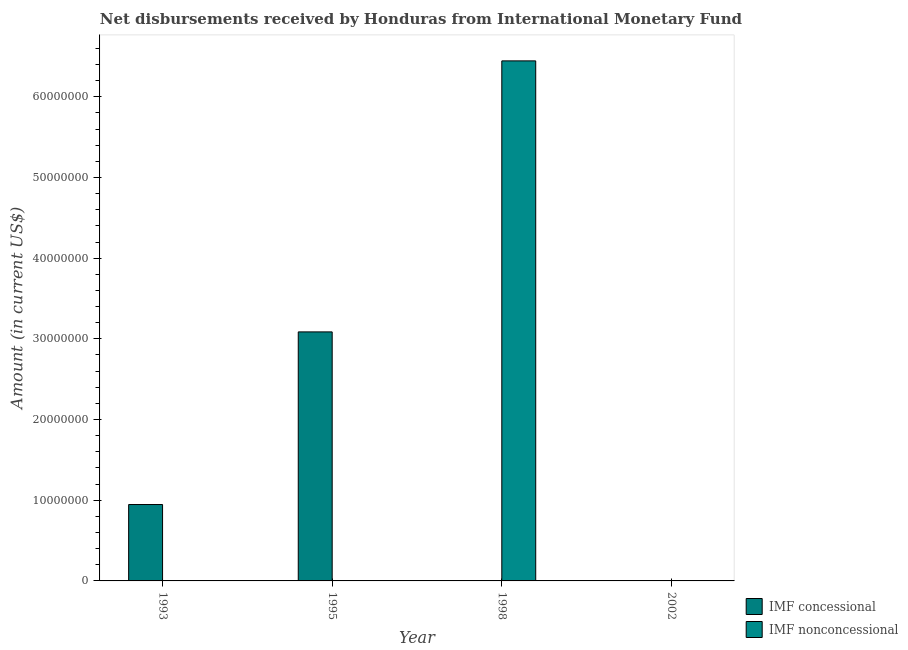Are the number of bars on each tick of the X-axis equal?
Ensure brevity in your answer.  No. How many bars are there on the 1st tick from the right?
Keep it short and to the point. 0. In how many cases, is the number of bars for a given year not equal to the number of legend labels?
Your answer should be compact. 4. Across all years, what is the maximum net concessional disbursements from imf?
Make the answer very short. 3.09e+07. What is the total net concessional disbursements from imf in the graph?
Your answer should be compact. 4.03e+07. What is the difference between the net concessional disbursements from imf in 1993 and that in 1995?
Offer a terse response. -2.14e+07. What is the average net non concessional disbursements from imf per year?
Give a very brief answer. 1.61e+07. What is the difference between the highest and the lowest net non concessional disbursements from imf?
Offer a terse response. 6.44e+07. Is the sum of the net concessional disbursements from imf in 1993 and 1995 greater than the maximum net non concessional disbursements from imf across all years?
Your answer should be compact. Yes. Are all the bars in the graph horizontal?
Your answer should be compact. No. How many years are there in the graph?
Make the answer very short. 4. What is the difference between two consecutive major ticks on the Y-axis?
Ensure brevity in your answer.  1.00e+07. Are the values on the major ticks of Y-axis written in scientific E-notation?
Your answer should be compact. No. Does the graph contain any zero values?
Your response must be concise. Yes. Does the graph contain grids?
Your answer should be very brief. No. What is the title of the graph?
Provide a succinct answer. Net disbursements received by Honduras from International Monetary Fund. What is the label or title of the X-axis?
Provide a short and direct response. Year. What is the label or title of the Y-axis?
Your response must be concise. Amount (in current US$). What is the Amount (in current US$) of IMF concessional in 1993?
Your answer should be compact. 9.47e+06. What is the Amount (in current US$) in IMF nonconcessional in 1993?
Make the answer very short. 0. What is the Amount (in current US$) of IMF concessional in 1995?
Give a very brief answer. 3.09e+07. What is the Amount (in current US$) in IMF nonconcessional in 1995?
Give a very brief answer. 0. What is the Amount (in current US$) in IMF nonconcessional in 1998?
Keep it short and to the point. 6.44e+07. What is the Amount (in current US$) in IMF concessional in 2002?
Make the answer very short. 0. Across all years, what is the maximum Amount (in current US$) of IMF concessional?
Make the answer very short. 3.09e+07. Across all years, what is the maximum Amount (in current US$) in IMF nonconcessional?
Your answer should be compact. 6.44e+07. Across all years, what is the minimum Amount (in current US$) in IMF concessional?
Offer a very short reply. 0. What is the total Amount (in current US$) in IMF concessional in the graph?
Make the answer very short. 4.03e+07. What is the total Amount (in current US$) in IMF nonconcessional in the graph?
Offer a terse response. 6.44e+07. What is the difference between the Amount (in current US$) in IMF concessional in 1993 and that in 1995?
Keep it short and to the point. -2.14e+07. What is the difference between the Amount (in current US$) of IMF concessional in 1993 and the Amount (in current US$) of IMF nonconcessional in 1998?
Your answer should be compact. -5.50e+07. What is the difference between the Amount (in current US$) of IMF concessional in 1995 and the Amount (in current US$) of IMF nonconcessional in 1998?
Offer a terse response. -3.36e+07. What is the average Amount (in current US$) of IMF concessional per year?
Give a very brief answer. 1.01e+07. What is the average Amount (in current US$) in IMF nonconcessional per year?
Your answer should be compact. 1.61e+07. What is the ratio of the Amount (in current US$) of IMF concessional in 1993 to that in 1995?
Your answer should be compact. 0.31. What is the difference between the highest and the lowest Amount (in current US$) in IMF concessional?
Your response must be concise. 3.09e+07. What is the difference between the highest and the lowest Amount (in current US$) of IMF nonconcessional?
Your answer should be compact. 6.44e+07. 